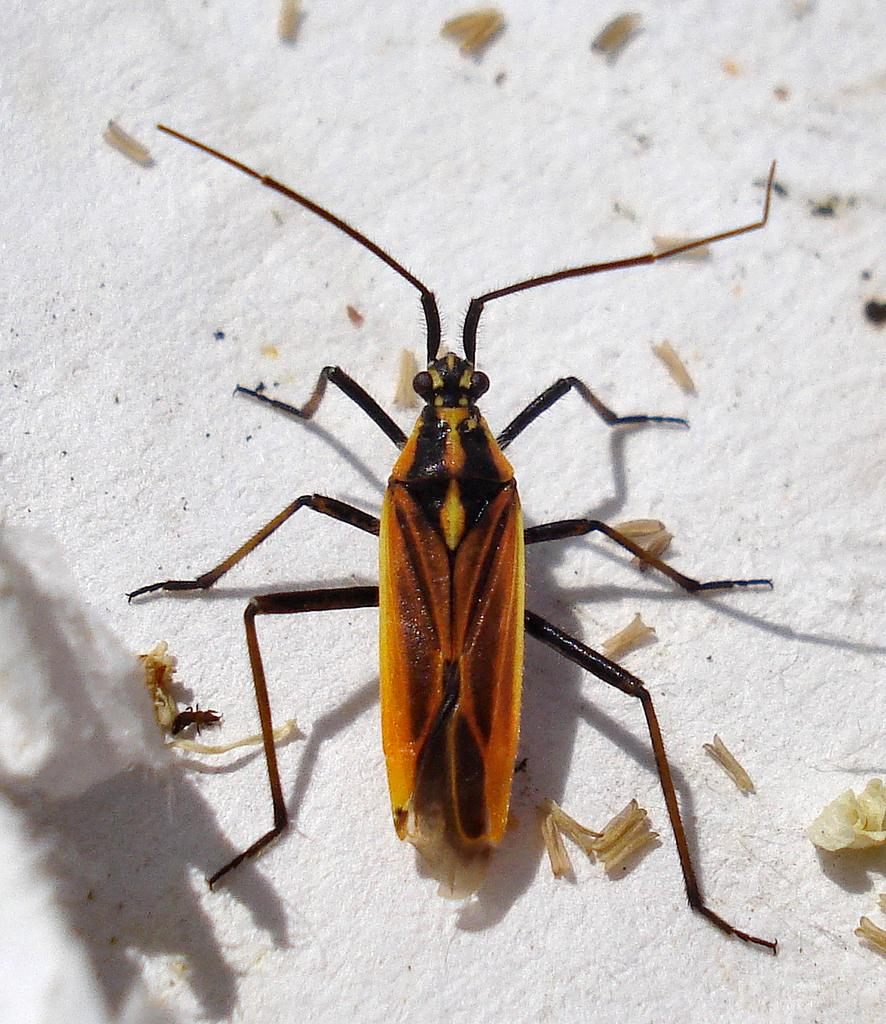What type of creature can be seen in the image? There is an insect in the image. What else is present in the image besides the insect? There are waste particles in the image. Where are the insect and waste particles located? The insect and waste particles are on a platform. What type of camera can be seen in the image? There is no camera present in the image. Is there an apple visible in the image? There is no apple present in the image. 